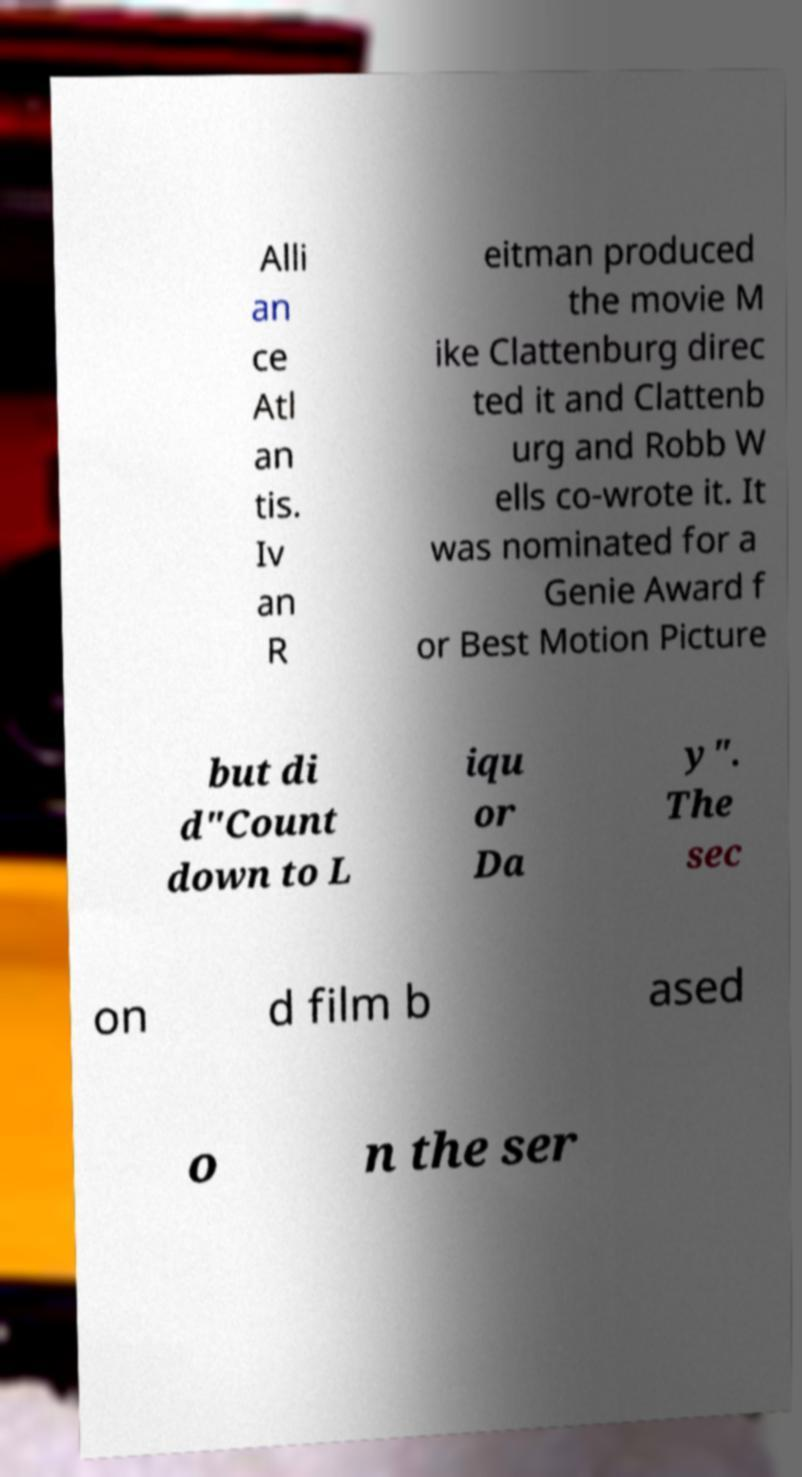For documentation purposes, I need the text within this image transcribed. Could you provide that? Alli an ce Atl an tis. Iv an R eitman produced the movie M ike Clattenburg direc ted it and Clattenb urg and Robb W ells co-wrote it. It was nominated for a Genie Award f or Best Motion Picture but di d"Count down to L iqu or Da y". The sec on d film b ased o n the ser 